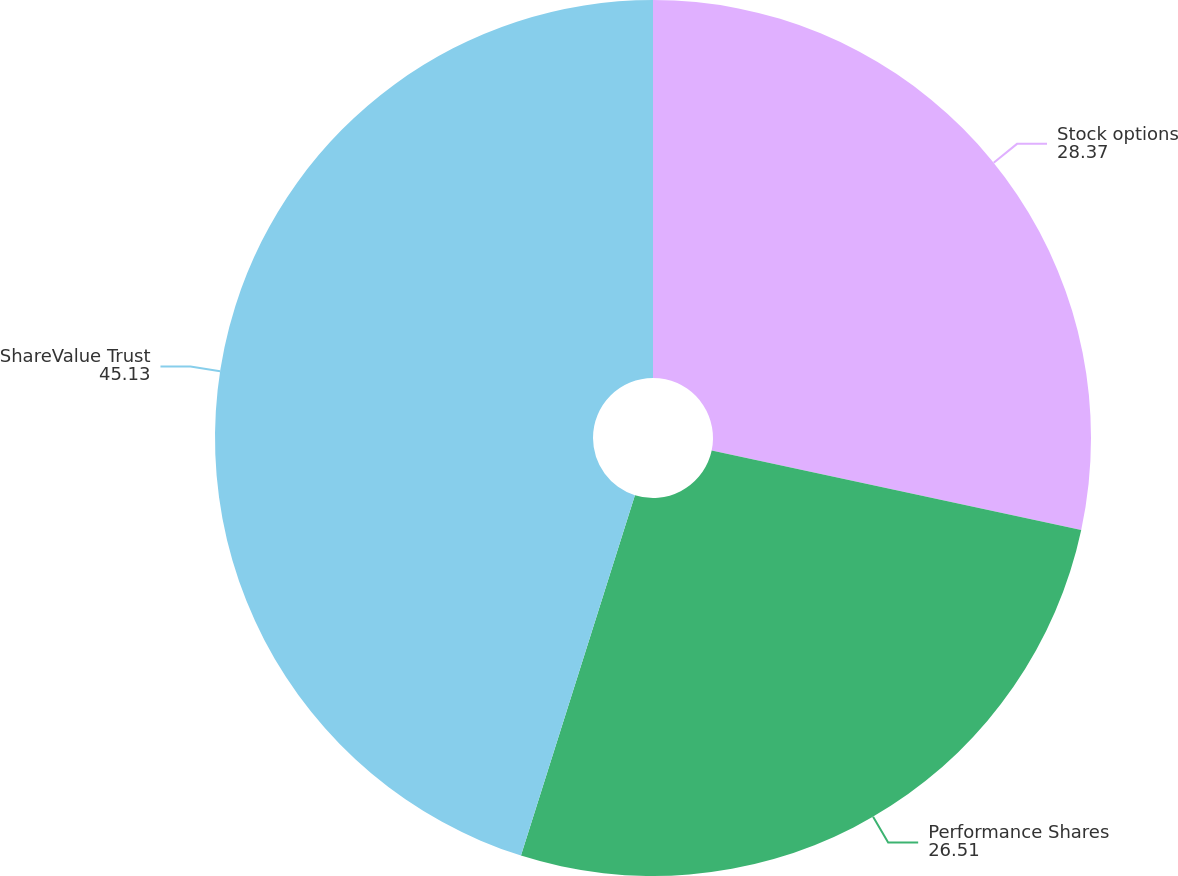Convert chart to OTSL. <chart><loc_0><loc_0><loc_500><loc_500><pie_chart><fcel>Stock options<fcel>Performance Shares<fcel>ShareValue Trust<nl><fcel>28.37%<fcel>26.51%<fcel>45.13%<nl></chart> 